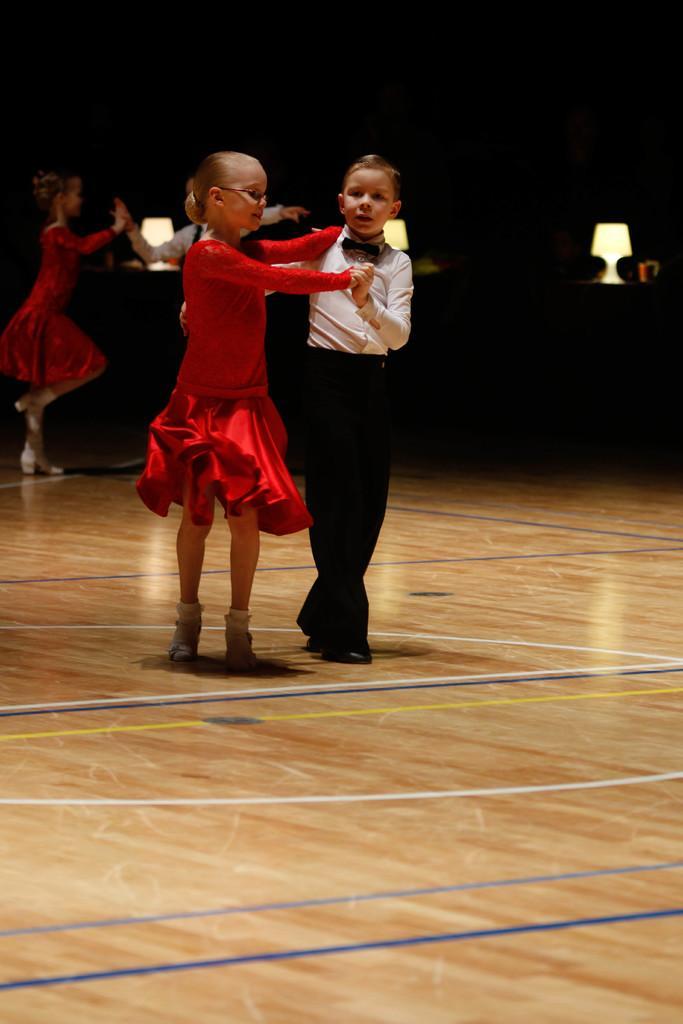In one or two sentences, can you explain what this image depicts? In this picture I can observe children dancing on the floor. There are girls and boys in this picture. Girls are wearing red color dresses and boys are wearing white and black color dresses. The floor is in brown color. The background is completely dark. 